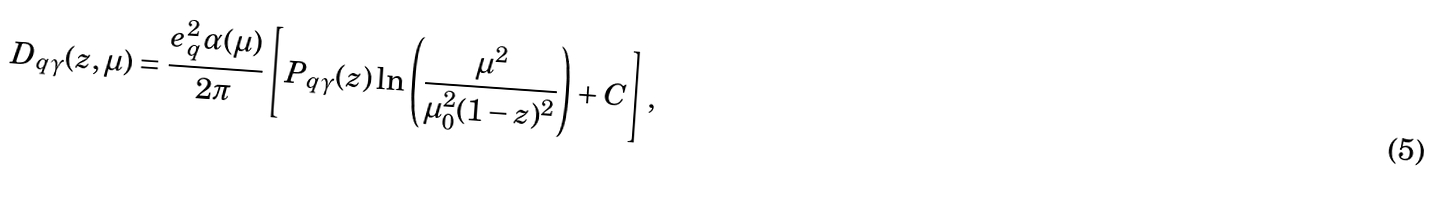Convert formula to latex. <formula><loc_0><loc_0><loc_500><loc_500>D _ { q \gamma } ( z , \mu ) = \frac { e _ { q } ^ { 2 } \alpha ( \mu ) } { 2 \pi } \left [ P _ { q \gamma } ( z ) \ln \left ( \frac { \mu ^ { 2 } } { \mu _ { 0 } ^ { 2 } ( 1 - z ) ^ { 2 } } \right ) + C \right ] ,</formula> 